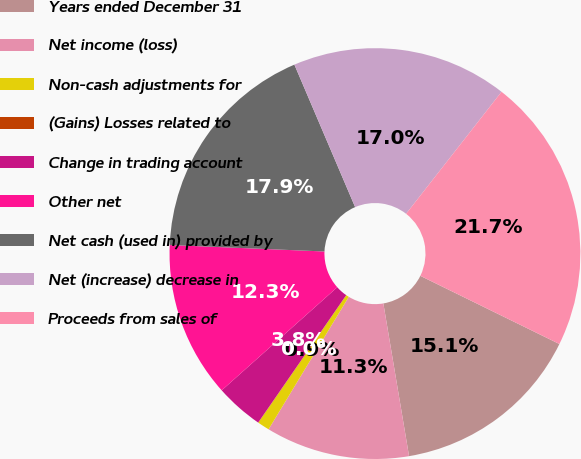Convert chart. <chart><loc_0><loc_0><loc_500><loc_500><pie_chart><fcel>Years ended December 31<fcel>Net income (loss)<fcel>Non-cash adjustments for<fcel>(Gains) Losses related to<fcel>Change in trading account<fcel>Other net<fcel>Net cash (used in) provided by<fcel>Net (increase) decrease in<fcel>Proceeds from sales of<nl><fcel>15.09%<fcel>11.32%<fcel>0.95%<fcel>0.01%<fcel>3.78%<fcel>12.26%<fcel>17.92%<fcel>16.98%<fcel>21.69%<nl></chart> 